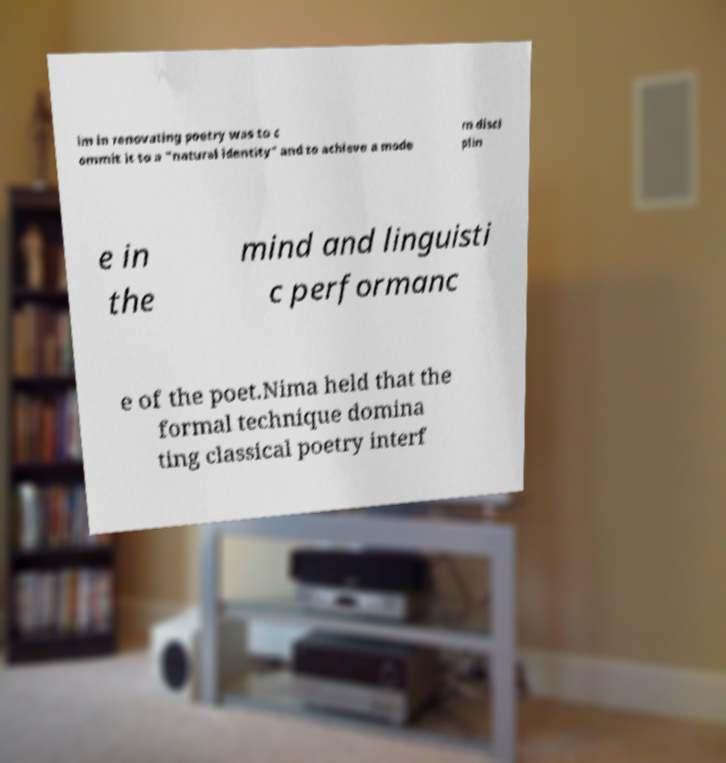There's text embedded in this image that I need extracted. Can you transcribe it verbatim? im in renovating poetry was to c ommit it to a "natural identity" and to achieve a mode rn disci plin e in the mind and linguisti c performanc e of the poet.Nima held that the formal technique domina ting classical poetry interf 